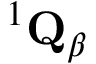Convert formula to latex. <formula><loc_0><loc_0><loc_500><loc_500>{ } ^ { 1 } { Q } _ { \beta }</formula> 